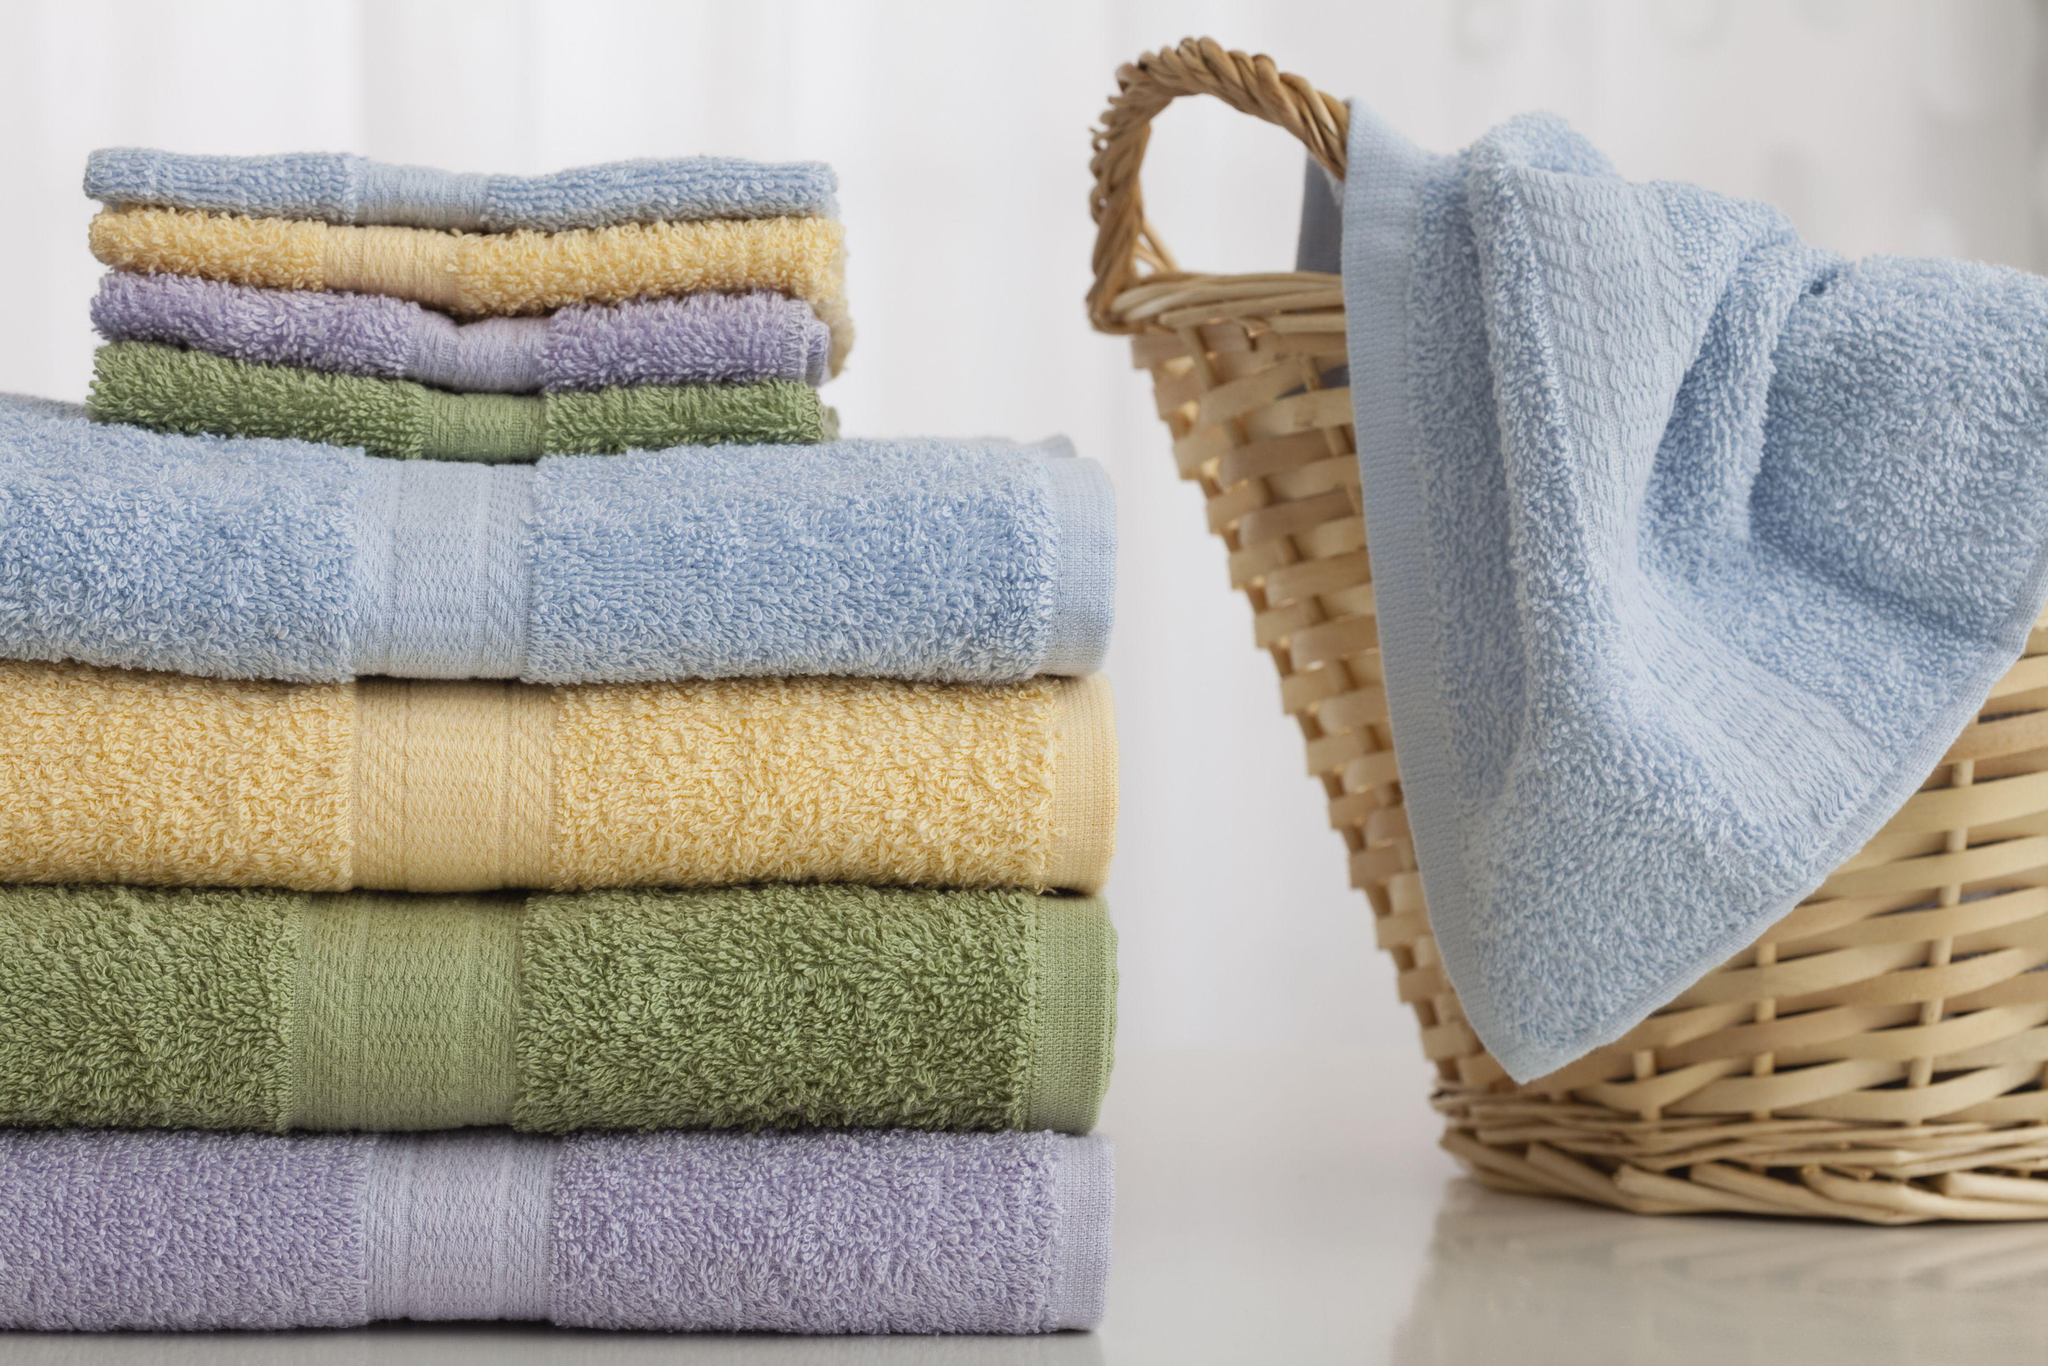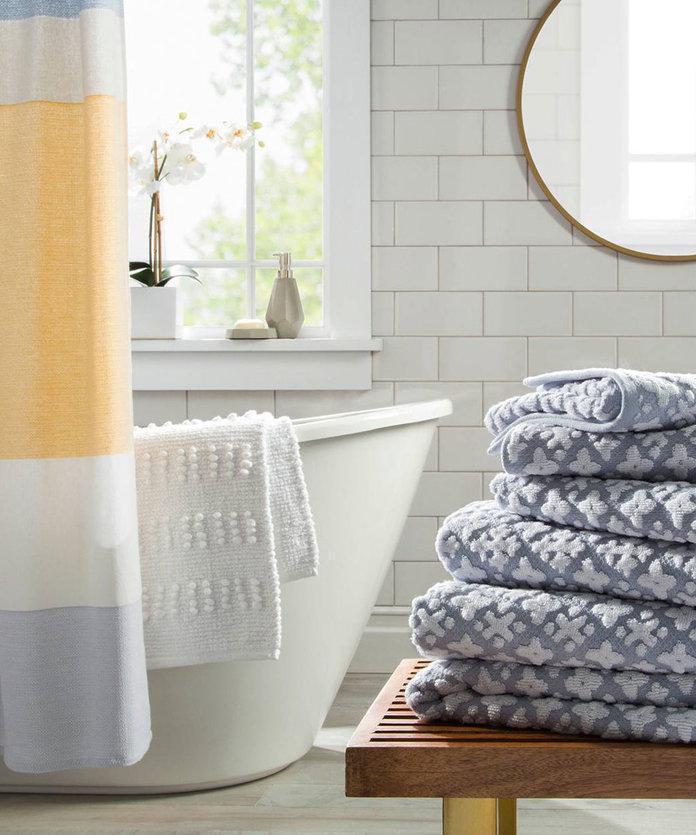The first image is the image on the left, the second image is the image on the right. Analyze the images presented: Is the assertion "There are towels hanging on racks." valid? Answer yes or no. No. The first image is the image on the left, the second image is the image on the right. Assess this claim about the two images: "A light colored towel is draped over the side of a freestanding tub.". Correct or not? Answer yes or no. Yes. 